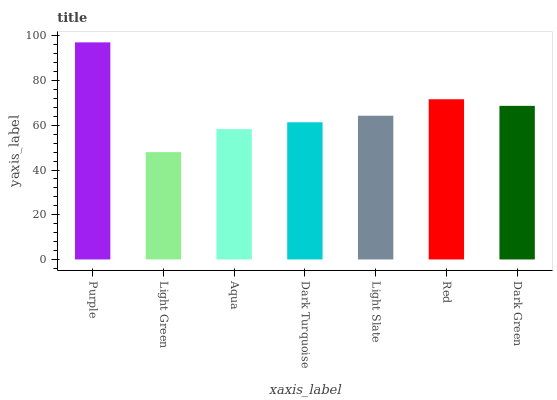Is Light Green the minimum?
Answer yes or no. Yes. Is Purple the maximum?
Answer yes or no. Yes. Is Aqua the minimum?
Answer yes or no. No. Is Aqua the maximum?
Answer yes or no. No. Is Aqua greater than Light Green?
Answer yes or no. Yes. Is Light Green less than Aqua?
Answer yes or no. Yes. Is Light Green greater than Aqua?
Answer yes or no. No. Is Aqua less than Light Green?
Answer yes or no. No. Is Light Slate the high median?
Answer yes or no. Yes. Is Light Slate the low median?
Answer yes or no. Yes. Is Dark Turquoise the high median?
Answer yes or no. No. Is Aqua the low median?
Answer yes or no. No. 